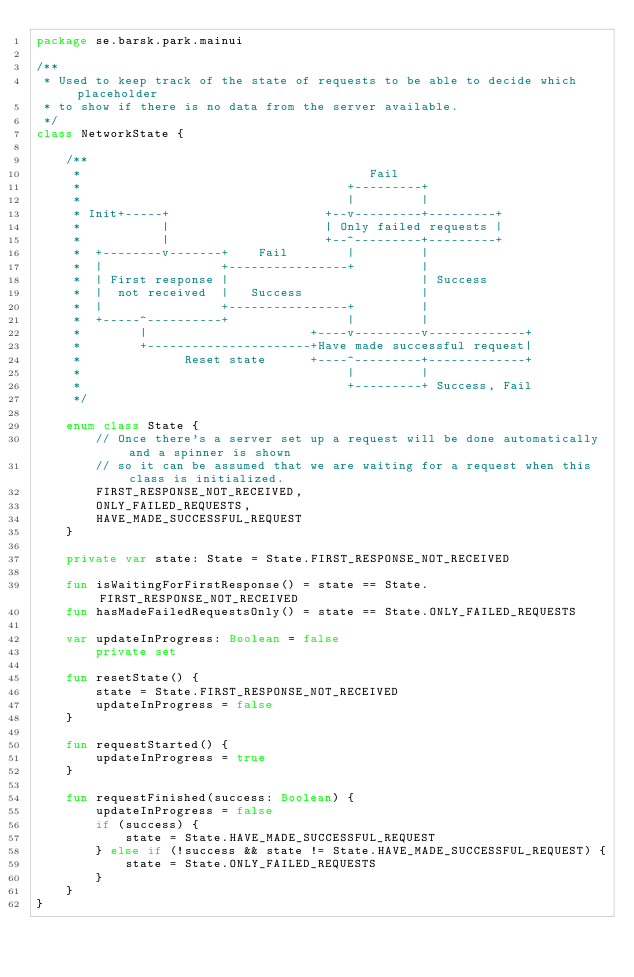<code> <loc_0><loc_0><loc_500><loc_500><_Kotlin_>package se.barsk.park.mainui

/**
 * Used to keep track of the state of requests to be able to decide which placeholder
 * to show if there is no data from the server available.
 */
class NetworkState {

    /**
     *                                       Fail
     *                                    +---------+
     *                                    |         |
     * Init+-----+                     +--v---------+---------+
     *           |                     | Only failed requests |
     *           |                     +--^---------+---------+
     *  +--------v-------+    Fail        |         |
     *  |                +----------------+         |
     *  | First response |                          | Success
     *  |  not received  |   Success                |
     *  |                +----------------+         |
     *  +-----^----------+                |         |
     *        |                      +----v---------v-------------+
     *        +----------------------+Have made successful request|
     *              Reset state      +----^---------+-------------+
     *                                    |         |
     *                                    +---------+ Success, Fail
     */

    enum class State {
        // Once there's a server set up a request will be done automatically and a spinner is shown
        // so it can be assumed that we are waiting for a request when this class is initialized.
        FIRST_RESPONSE_NOT_RECEIVED,
        ONLY_FAILED_REQUESTS,
        HAVE_MADE_SUCCESSFUL_REQUEST
    }

    private var state: State = State.FIRST_RESPONSE_NOT_RECEIVED

    fun isWaitingForFirstResponse() = state == State.FIRST_RESPONSE_NOT_RECEIVED
    fun hasMadeFailedRequestsOnly() = state == State.ONLY_FAILED_REQUESTS

    var updateInProgress: Boolean = false
        private set

    fun resetState() {
        state = State.FIRST_RESPONSE_NOT_RECEIVED
        updateInProgress = false
    }

    fun requestStarted() {
        updateInProgress = true
    }

    fun requestFinished(success: Boolean) {
        updateInProgress = false
        if (success) {
            state = State.HAVE_MADE_SUCCESSFUL_REQUEST
        } else if (!success && state != State.HAVE_MADE_SUCCESSFUL_REQUEST) {
            state = State.ONLY_FAILED_REQUESTS
        }
    }
}</code> 